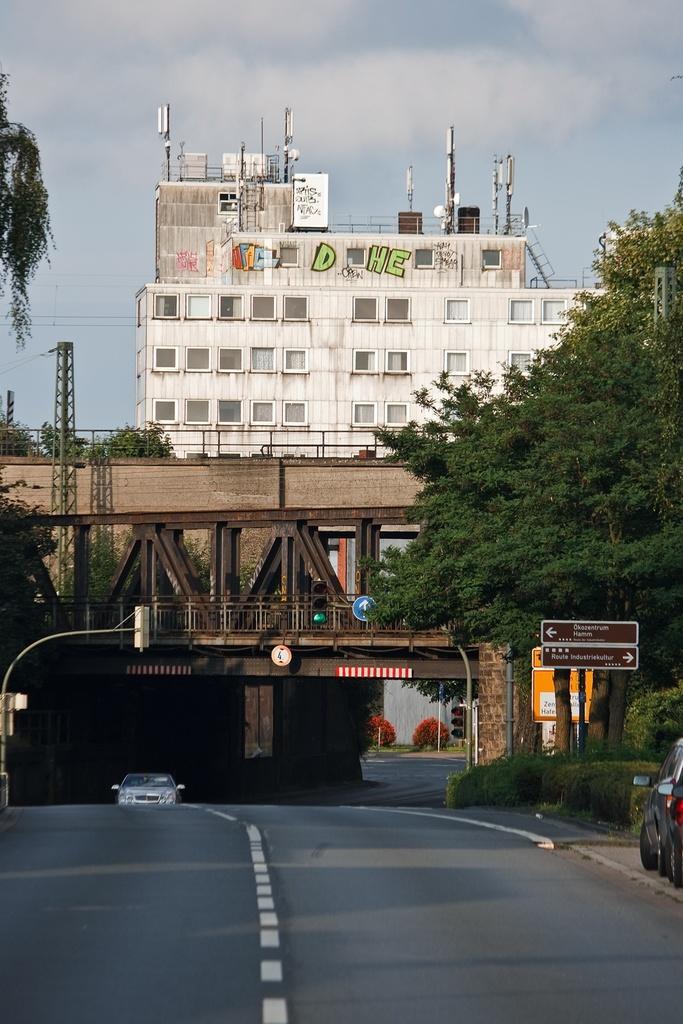Please provide a concise description of this image. There is a car on the road as we can see at the bottom of this image. We can see a bridge, trees and a building in the middle of this image and the sky in the background. 